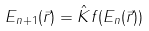Convert formula to latex. <formula><loc_0><loc_0><loc_500><loc_500>\ E _ { n + 1 } ( \vec { r } ) = \hat { K } f ( E _ { n } ( \vec { r } ) )</formula> 